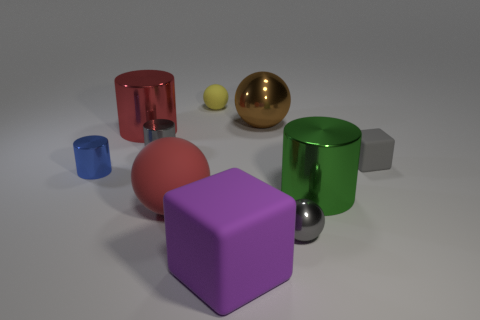Subtract all small gray shiny cylinders. How many cylinders are left? 3 Subtract all gray cylinders. How many cylinders are left? 3 Subtract 0 blue spheres. How many objects are left? 10 Subtract all spheres. How many objects are left? 6 Subtract 1 spheres. How many spheres are left? 3 Subtract all gray blocks. Subtract all cyan cylinders. How many blocks are left? 1 Subtract all large purple rubber things. Subtract all large objects. How many objects are left? 4 Add 4 yellow matte spheres. How many yellow matte spheres are left? 5 Add 8 gray rubber blocks. How many gray rubber blocks exist? 9 